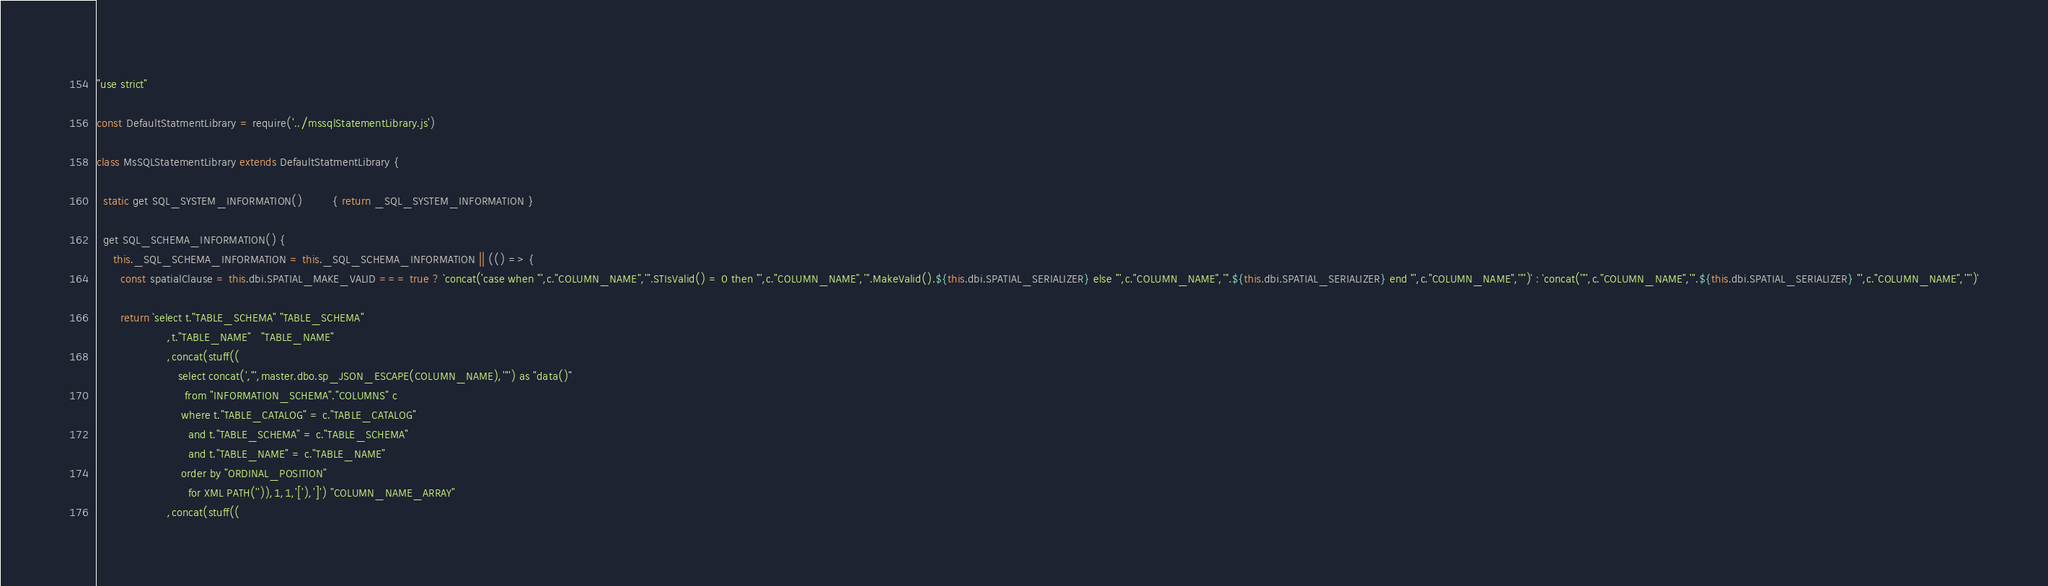<code> <loc_0><loc_0><loc_500><loc_500><_JavaScript_>"use strict" 

const DefaultStatmentLibrary = require('../mssqlStatementLibrary.js')

class MsSQLStatementLibrary extends DefaultStatmentLibrary {

  static get SQL_SYSTEM_INFORMATION()         { return _SQL_SYSTEM_INFORMATION }

  get SQL_SCHEMA_INFORMATION() {
     this._SQL_SCHEMA_INFORMATION = this._SQL_SCHEMA_INFORMATION || (() => { 
       const spatialClause = this.dbi.SPATIAL_MAKE_VALID === true ? `concat('case when "',c."COLUMN_NAME",'".STIsValid() = 0 then "',c."COLUMN_NAME",'".MakeValid().${this.dbi.SPATIAL_SERIALIZER} else "',c."COLUMN_NAME",'".${this.dbi.SPATIAL_SERIALIZER} end "',c."COLUMN_NAME",'"')` : `concat('"',c."COLUMN_NAME",'".${this.dbi.SPATIAL_SERIALIZER} "',c."COLUMN_NAME",'"')`
    
       return `select t."TABLE_SCHEMA" "TABLE_SCHEMA"
                     ,t."TABLE_NAME"   "TABLE_NAME"
                     ,concat(stuff((
                        select concat(',"',master.dbo.sp_JSON_ESCAPE(COLUMN_NAME),'"') as "data()"
                          from "INFORMATION_SCHEMA"."COLUMNS" c
                         where t."TABLE_CATALOG" = c."TABLE_CATALOG"
                           and t."TABLE_SCHEMA" = c."TABLE_SCHEMA"
                           and t."TABLE_NAME" = c."TABLE_NAME"
                         order by "ORDINAL_POSITION"
                           for XML PATH('')),1,1,'['),']') "COLUMN_NAME_ARRAY" 
                     ,concat(stuff((</code> 